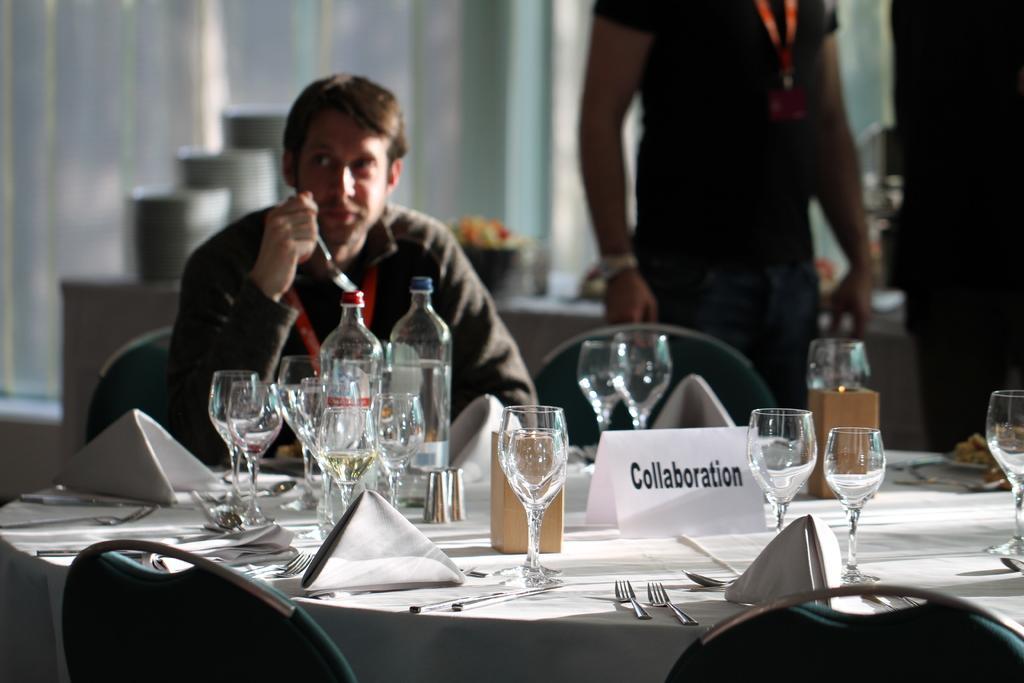How would you summarize this image in a sentence or two? In this image I can see a man sitting on a chair. I can also see few chairs and number of glasses. 